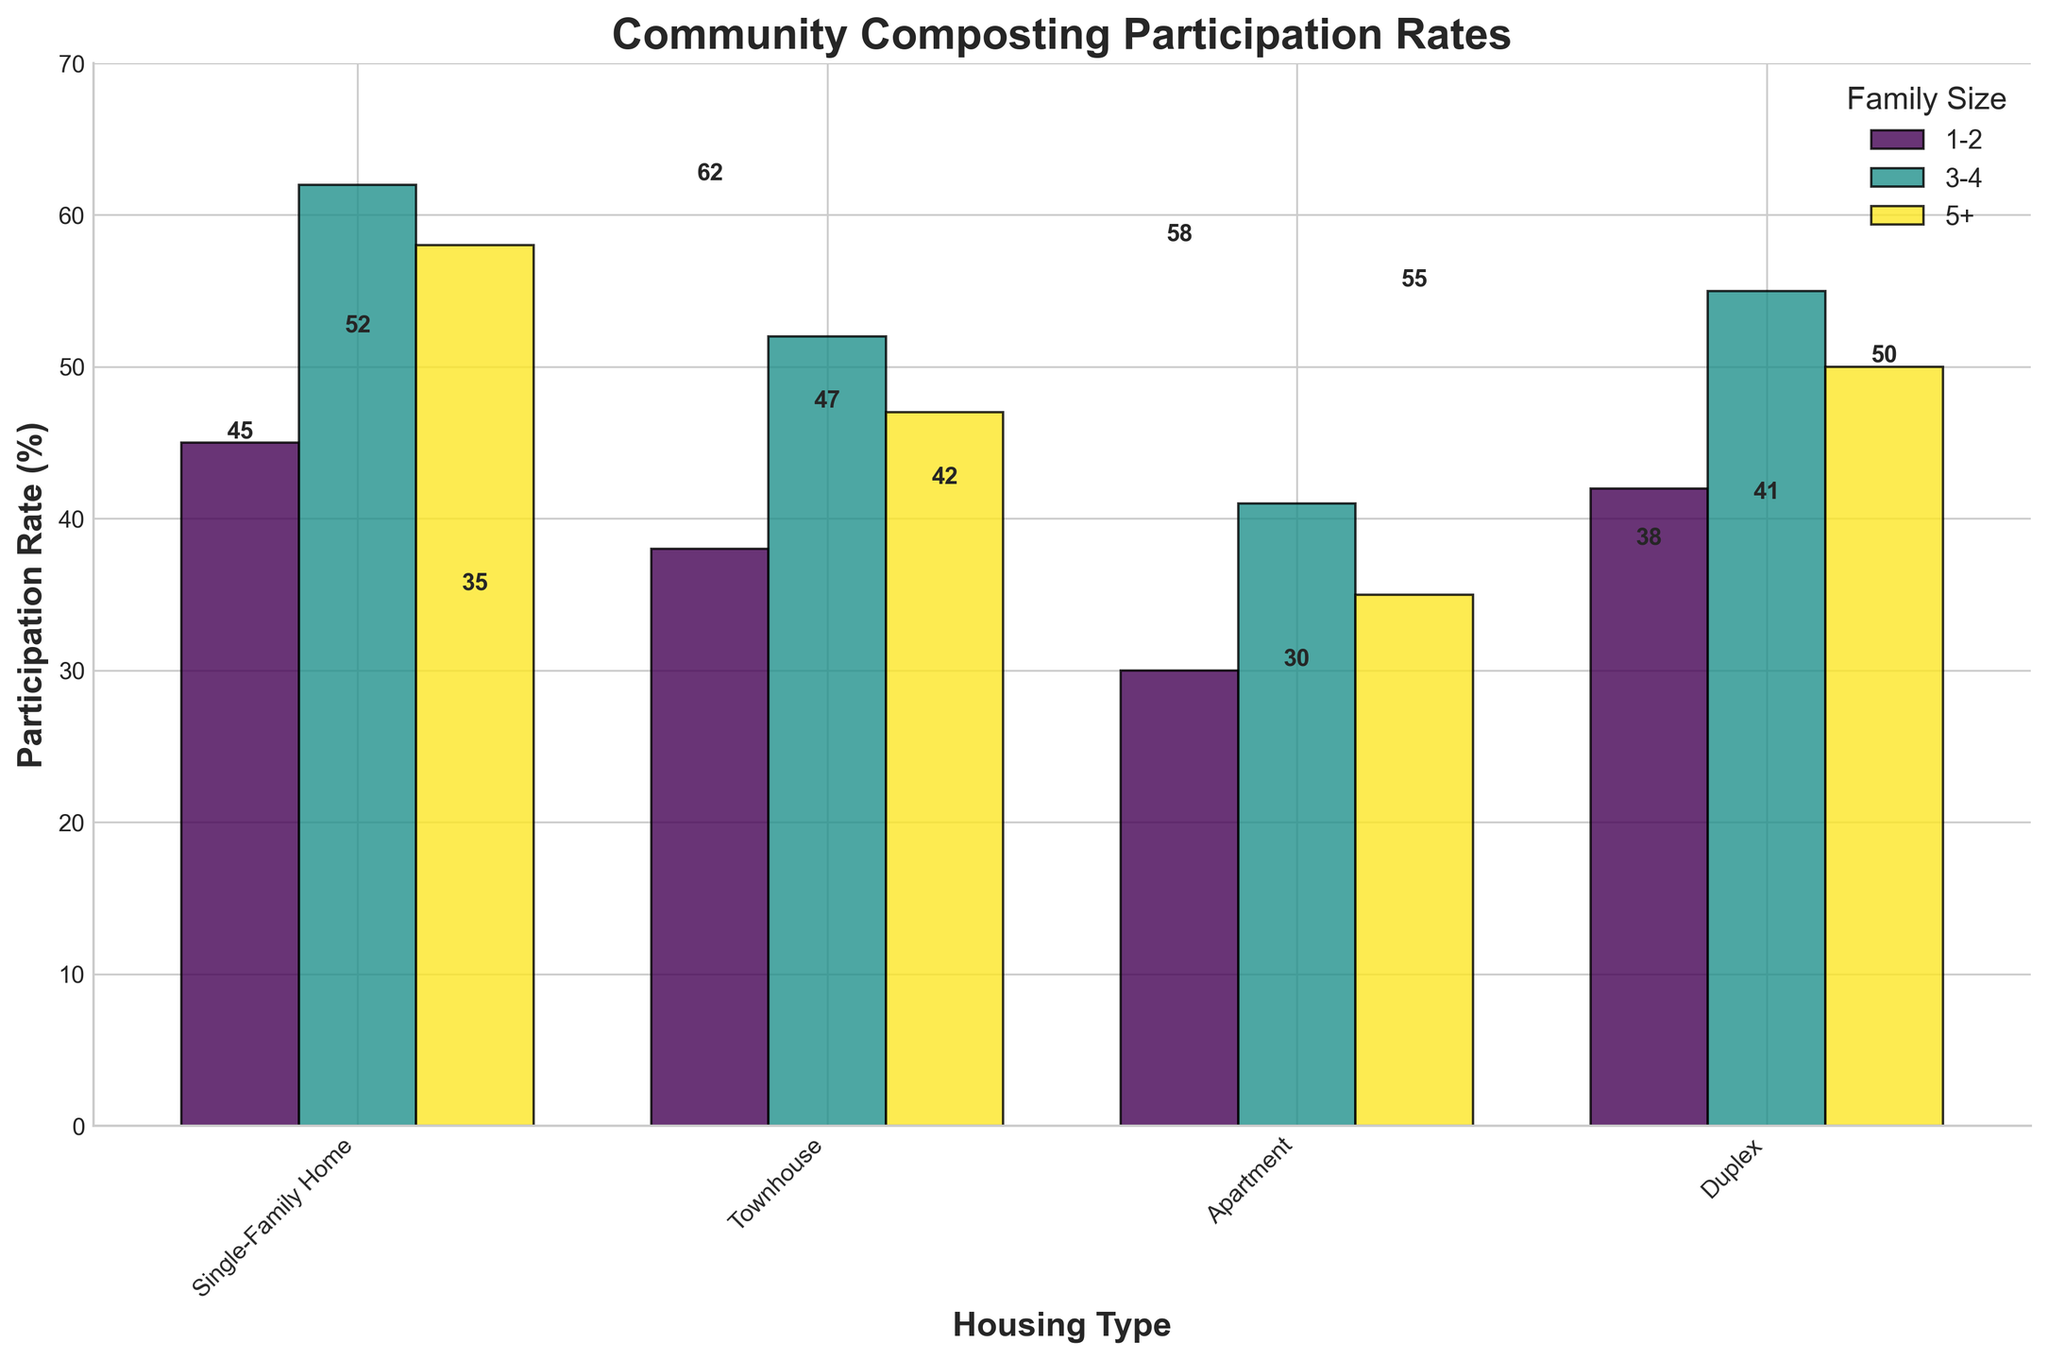What's the title of the figure? The title is what appears at the top of the figure. It helps identify the overall topic or main point of the graphical content shown.
Answer: Community Composting Participation Rates What is the participation rate for Single-Family Homes with 3-4 family members? To find this, locate the bar that represents Single-Family Homes and then identify the specific segment for 3-4 family members, noting the height of the bar.
Answer: 62% Which housing type has the lowest participation rate for the 1-2 family members category? Compare the heights of the bars for each housing type under the 1-2 family members category. The shortest bar indicates the lowest participation rate.
Answer: Apartment What's the difference in participation rate between Single-Family Homes and Apartments for 5+ family members? Find the participation rates for both categories (Single-Family Homes and Apartments) with 5+ family members and calculate the difference between these two values.
Answer: 58 - 35 = 23% Which family size within Duplexes has the highest participation rate? Look at the bars for Duplexes and compare their heights across the different family sizes. The tallest bar indicates the highest participation rate.
Answer: 3-4 Across all housing types, how does the participation rate generally trend as family size increases? Observe the patterns for all family sizes within each housing type and see if there is an increasing, decreasing, or no clear trend as you move from smaller to larger family sizes.
Answer: Generally increases What is the participation rate for Townhouses with 3-4 family members? Identify the bar segment that represents participation for Townhouses with 3-4 family members by looking at the relevant bar for Townhouses and noting the height.
Answer: 52% Which housing type shows the smallest variation in participation rate across different family sizes? Check the bars for each housing type and note the range of participation rates. The housing type with the smallest differences between its highest and lowest bars shows the least variation.
Answer: Townhouse Is there any housing type where the participation rate decreases as family size increases? Observe each housing type to check if there is a decreasing trend in the participation rate as the family size goes from 1-2 to 3-4 to 5+.
Answer: No 